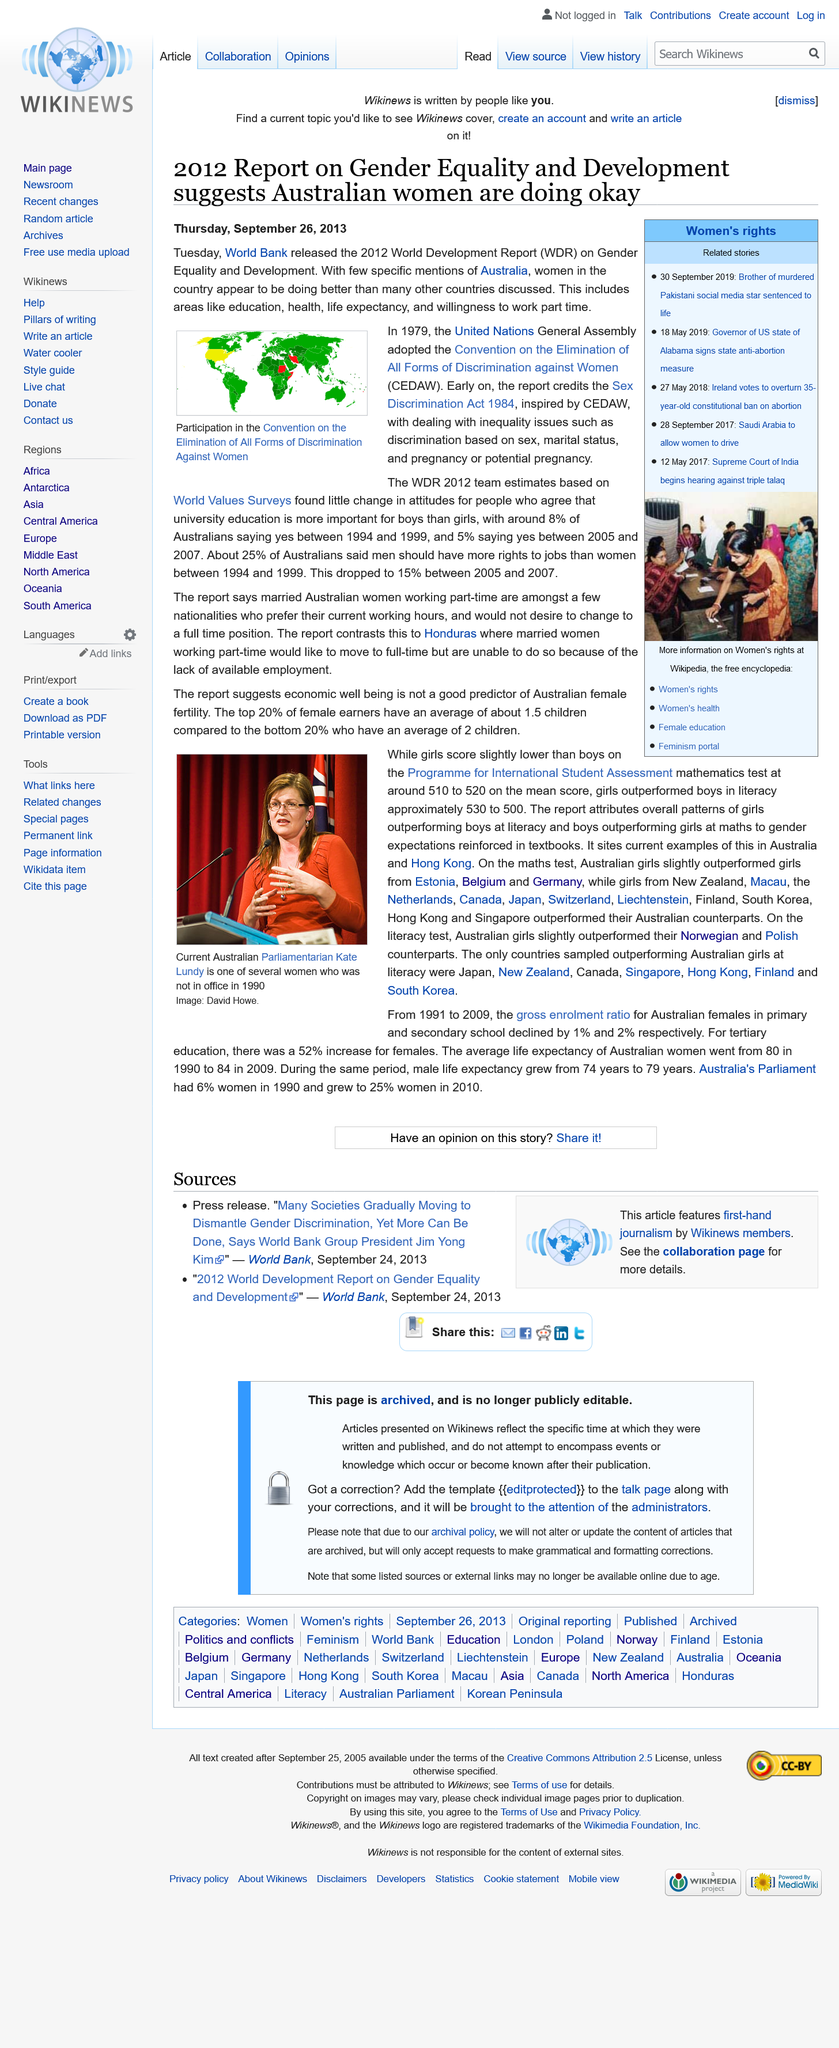List a handful of essential elements in this visual. The image depicts the participation in the Convention on the Elimination of All Forms of Discrimination Against Women, as evidenced by the presence of multiple individuals, including women, of various ages and ethnicities, gathered together in a room with a banner prominently displayed that reads 'CEDAW' and a United Nations logo. In the period between 1994 and 1999, approximately 25% of Australians believed that men should have more job rights than women. The World Bank released the 2012 World Development Report on Gender Equality and Development on Tuesday, September 24, 2013. 